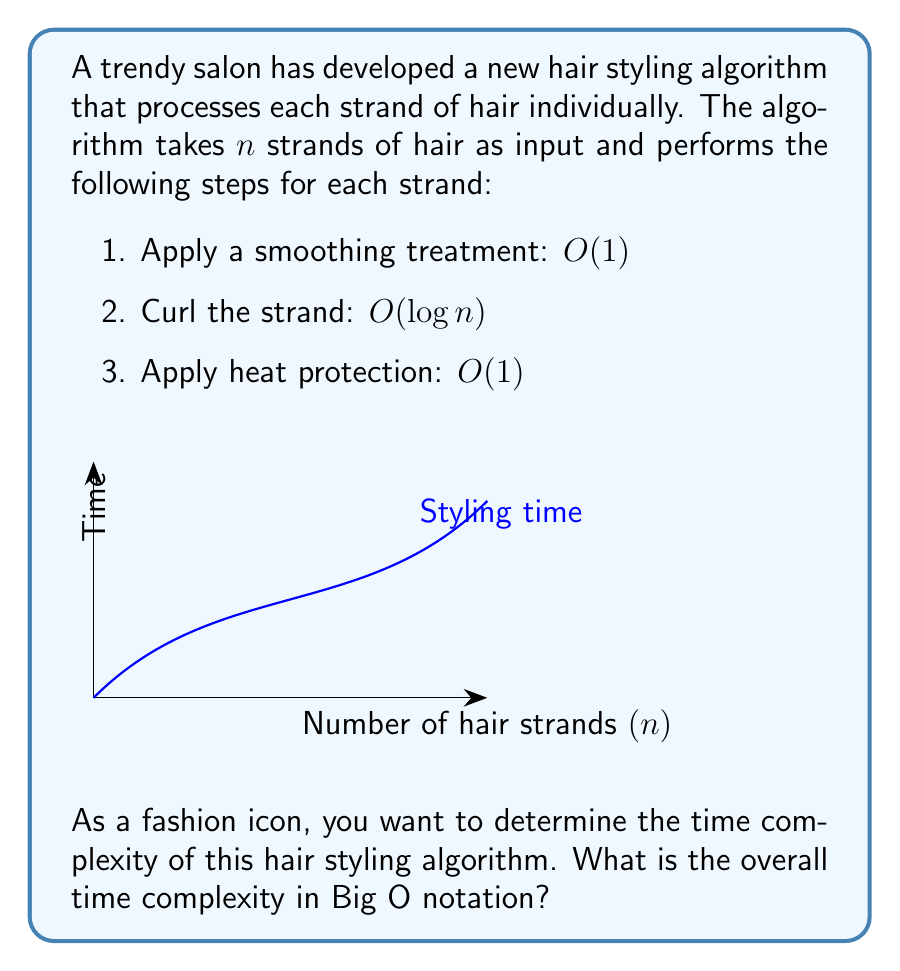Can you answer this question? Let's analyze the time complexity step by step:

1. We have $n$ strands of hair, and for each strand, we perform three operations.

2. Let's look at the time complexity of each operation:
   - Smoothing treatment: $O(1)$
   - Curling: $O(\log n)$
   - Heat protection: $O(1)$

3. For a single strand, the time complexity is:
   $O(1) + O(\log n) + O(1) = O(\log n)$

4. Since we perform these operations for each of the $n$ strands, we multiply the complexity by $n$:
   $n \cdot O(\log n) = O(n \log n)$

5. This means that as the number of hair strands increases, the time taken by the algorithm grows in a linearithmic fashion.

6. The dominant term in this algorithm is $O(n \log n)$, which comes from the curling step being applied to all strands.

Therefore, the overall time complexity of the hair styling algorithm is $O(n \log n)$.
Answer: $O(n \log n)$ 